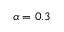<formula> <loc_0><loc_0><loc_500><loc_500>\alpha = 0 . 3</formula> 